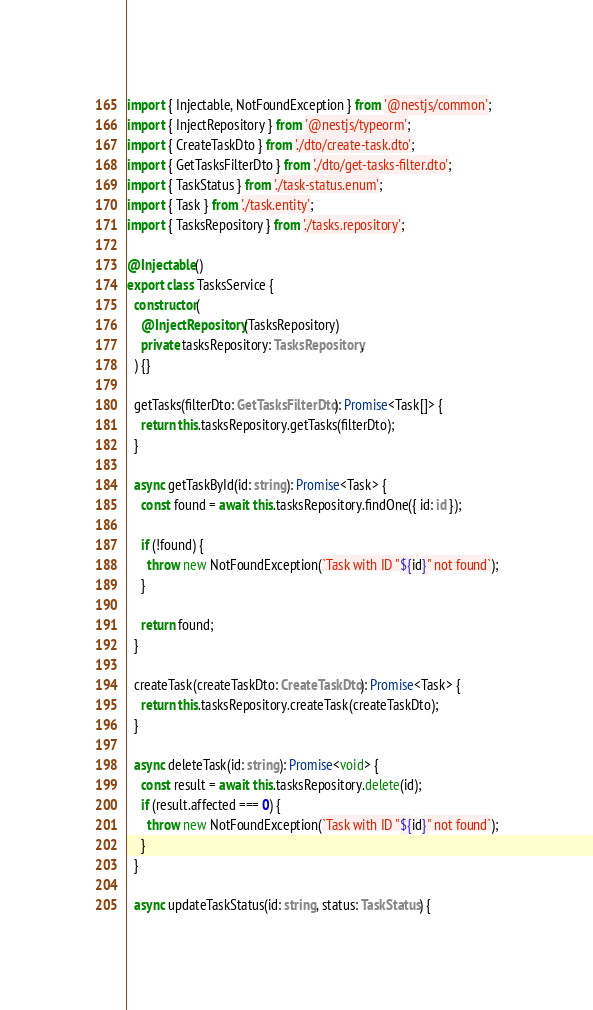<code> <loc_0><loc_0><loc_500><loc_500><_TypeScript_>import { Injectable, NotFoundException } from '@nestjs/common';
import { InjectRepository } from '@nestjs/typeorm';
import { CreateTaskDto } from './dto/create-task.dto';
import { GetTasksFilterDto } from './dto/get-tasks-filter.dto';
import { TaskStatus } from './task-status.enum';
import { Task } from './task.entity';
import { TasksRepository } from './tasks.repository';

@Injectable()
export class TasksService {
  constructor(
    @InjectRepository(TasksRepository)
    private tasksRepository: TasksRepository,
  ) {}

  getTasks(filterDto: GetTasksFilterDto): Promise<Task[]> {
    return this.tasksRepository.getTasks(filterDto);
  }

  async getTaskById(id: string): Promise<Task> {
    const found = await this.tasksRepository.findOne({ id: id });

    if (!found) {
      throw new NotFoundException(`Task with ID "${id}" not found`);
    }

    return found;
  }

  createTask(createTaskDto: CreateTaskDto): Promise<Task> {
    return this.tasksRepository.createTask(createTaskDto);
  }

  async deleteTask(id: string): Promise<void> {
    const result = await this.tasksRepository.delete(id);
    if (result.affected === 0) {
      throw new NotFoundException(`Task with ID "${id}" not found`);
    }
  }

  async updateTaskStatus(id: string, status: TaskStatus) {</code> 